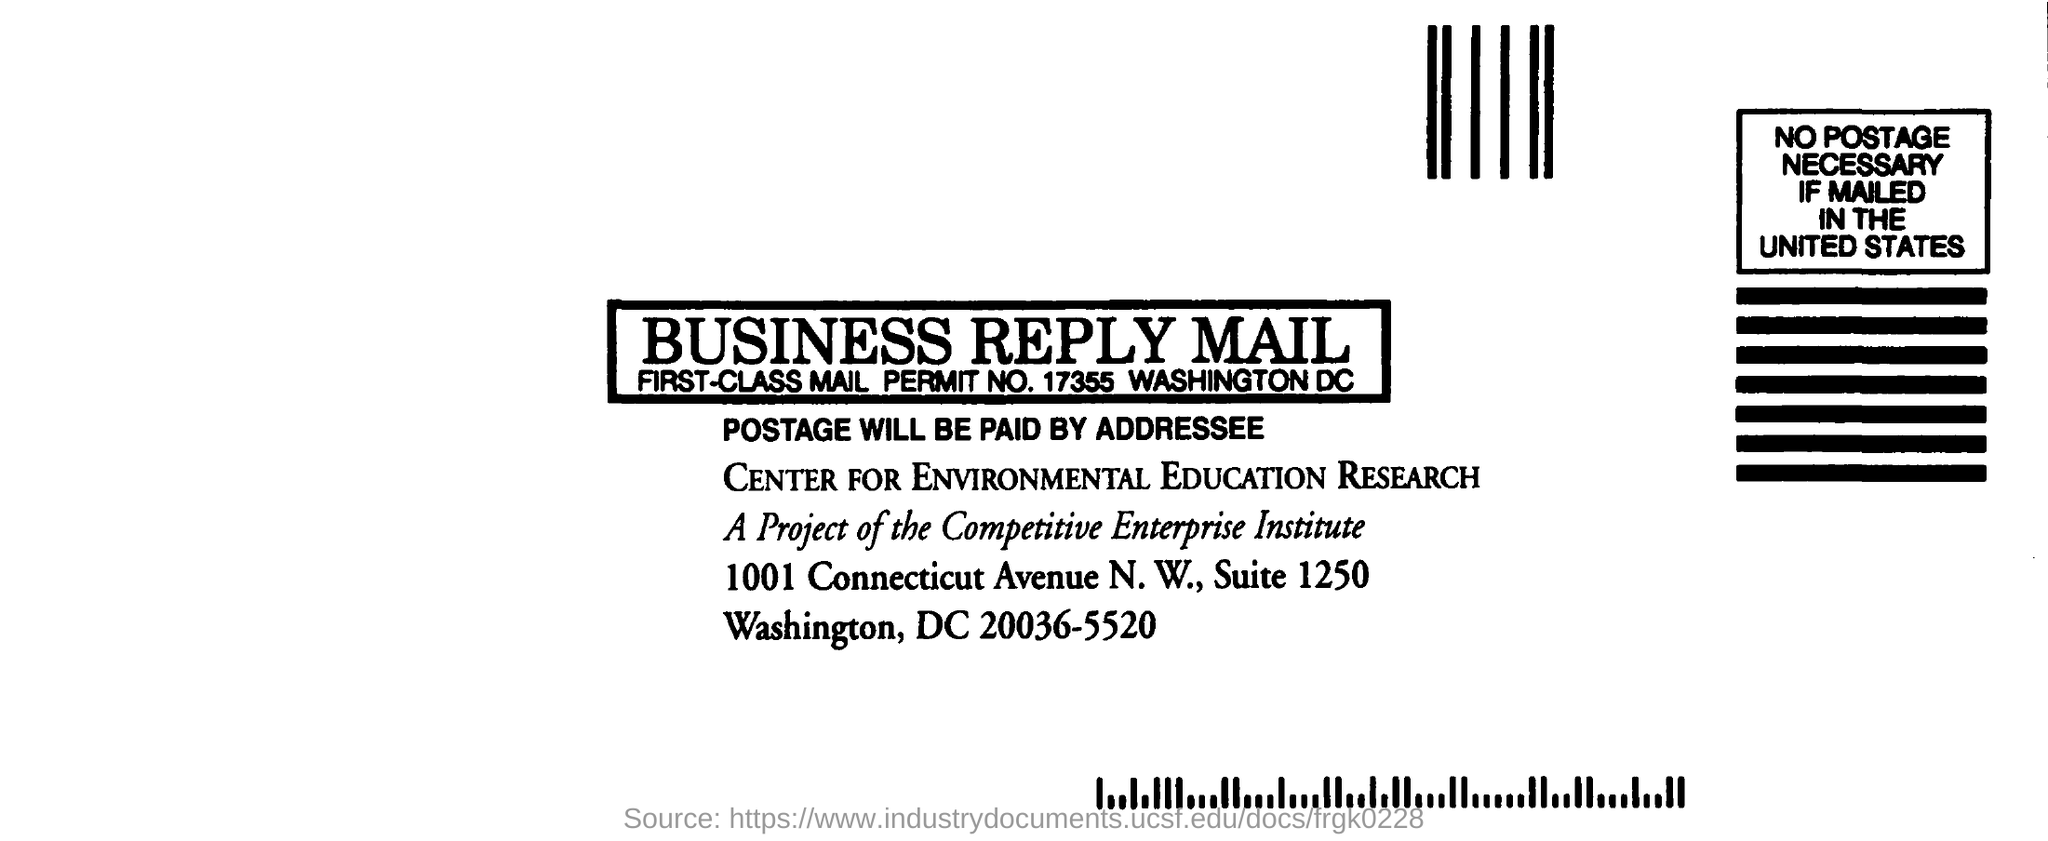Draw attention to some important aspects in this diagram. The main title of the document is "Business Reply Mail. 